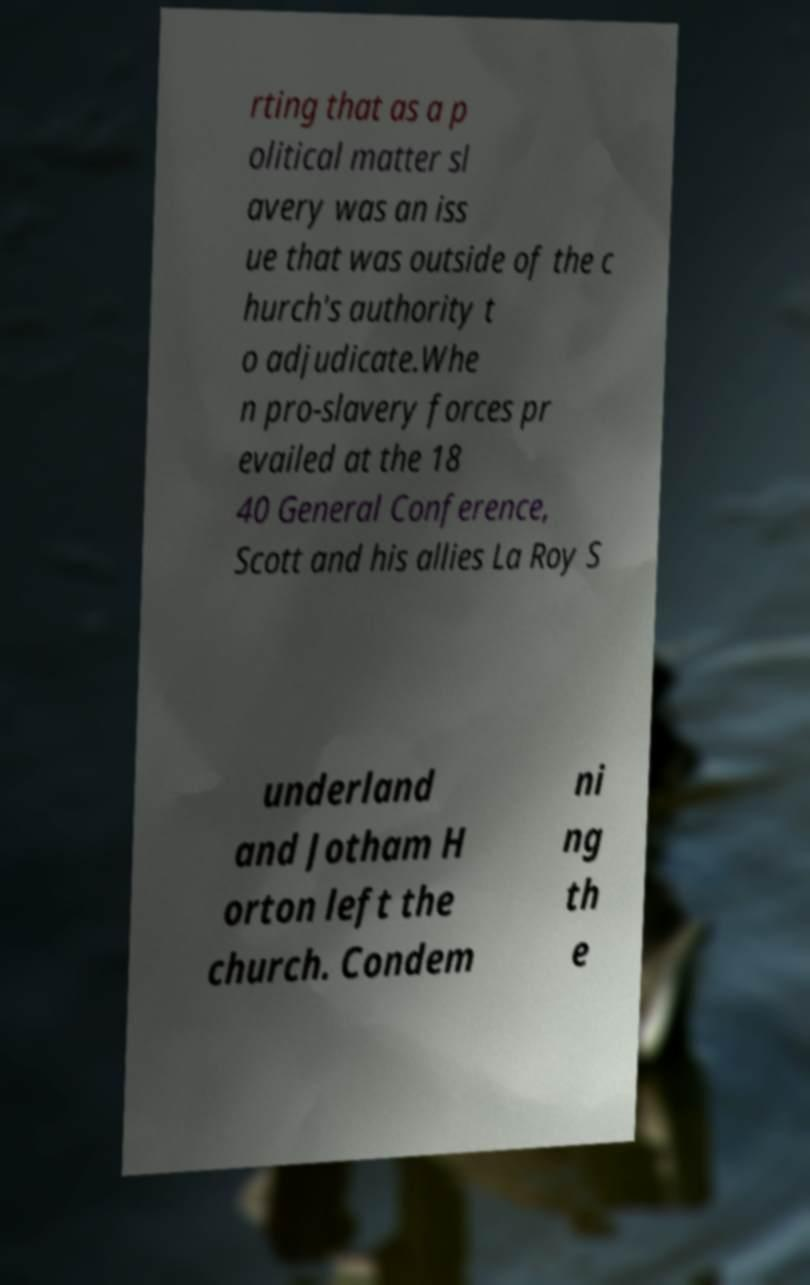Please identify and transcribe the text found in this image. rting that as a p olitical matter sl avery was an iss ue that was outside of the c hurch's authority t o adjudicate.Whe n pro-slavery forces pr evailed at the 18 40 General Conference, Scott and his allies La Roy S underland and Jotham H orton left the church. Condem ni ng th e 